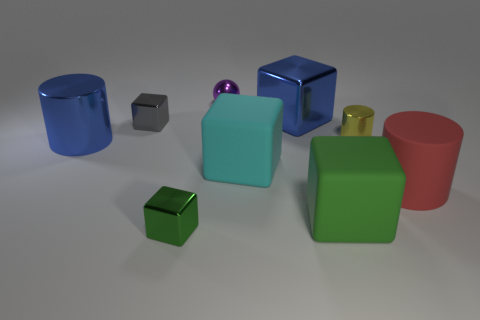There is a block that is to the right of the big shiny cube; is it the same size as the blue metallic object left of the large metallic cube?
Ensure brevity in your answer.  Yes. Are there more small shiny cylinders on the right side of the large cyan rubber block than purple shiny balls to the right of the purple metal sphere?
Your answer should be very brief. Yes. What number of other small purple metal things are the same shape as the tiny purple shiny object?
Offer a terse response. 0. There is a red thing that is the same size as the cyan matte block; what is its material?
Give a very brief answer. Rubber. Are there any large purple cylinders made of the same material as the small purple object?
Give a very brief answer. No. Are there fewer metallic cubes on the right side of the ball than big blue metallic blocks?
Offer a very short reply. No. The big object that is to the left of the tiny cube behind the big matte cylinder is made of what material?
Make the answer very short. Metal. What shape is the matte thing that is both left of the yellow object and on the right side of the cyan block?
Keep it short and to the point. Cube. How many other objects are the same color as the large shiny cylinder?
Ensure brevity in your answer.  1. How many objects are either things in front of the metal ball or blue cubes?
Your answer should be very brief. 8. 